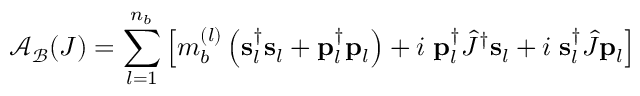Convert formula to latex. <formula><loc_0><loc_0><loc_500><loc_500>{ \mathcal { A } } _ { \mathcal { B } } ( J ) = \sum _ { l = 1 } ^ { n _ { b } } \left [ m _ { b } ^ { ( l ) } \left ( { s } _ { l } ^ { \dag } { s } _ { l } + { p } _ { l } ^ { \dag } { p } _ { l } \right ) + i \, { p } _ { l } ^ { \dag } \hat { J } ^ { \dag } { s } _ { l } + i \, { s } _ { l } ^ { \dag } \hat { J } { p } _ { l } \right ]</formula> 